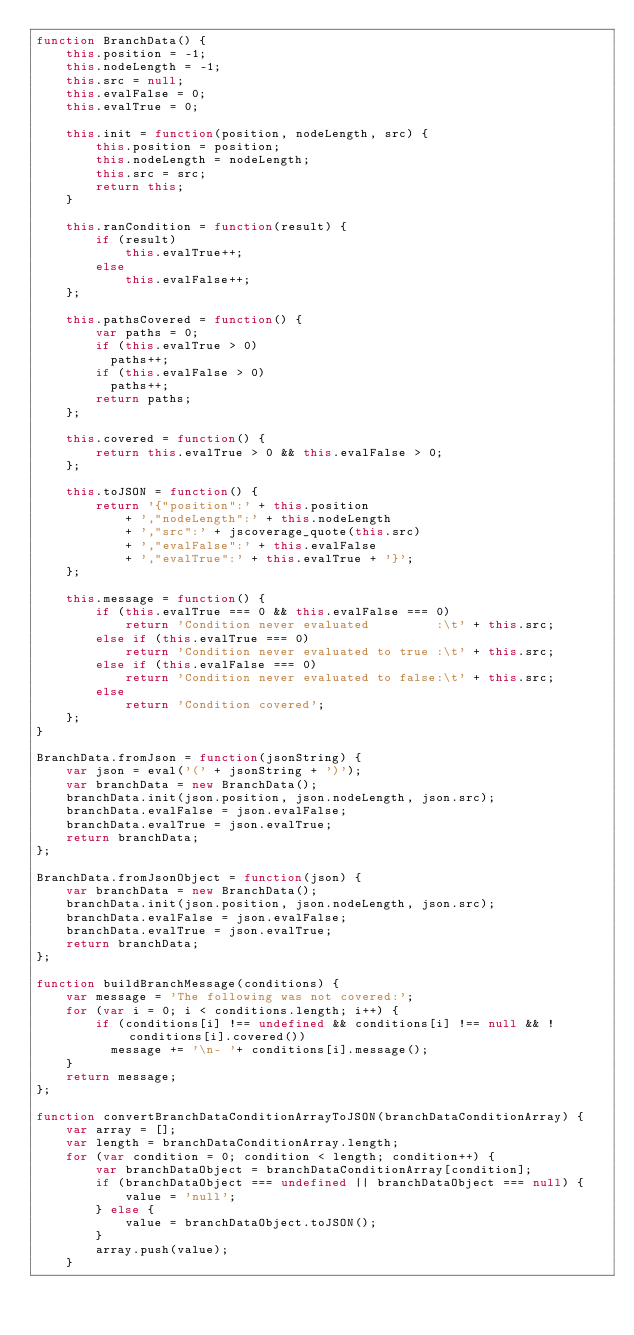Convert code to text. <code><loc_0><loc_0><loc_500><loc_500><_JavaScript_>function BranchData() {
    this.position = -1;
    this.nodeLength = -1;
    this.src = null;
    this.evalFalse = 0;
    this.evalTrue = 0;

    this.init = function(position, nodeLength, src) {
        this.position = position;
        this.nodeLength = nodeLength;
        this.src = src;
        return this;
    }

    this.ranCondition = function(result) {
        if (result)
            this.evalTrue++;
        else
            this.evalFalse++;
    };

    this.pathsCovered = function() {
        var paths = 0;
        if (this.evalTrue > 0)
          paths++;
        if (this.evalFalse > 0)
          paths++;
        return paths;
    };

    this.covered = function() {
        return this.evalTrue > 0 && this.evalFalse > 0;
    };

    this.toJSON = function() {
        return '{"position":' + this.position
            + ',"nodeLength":' + this.nodeLength
            + ',"src":' + jscoverage_quote(this.src)
            + ',"evalFalse":' + this.evalFalse
            + ',"evalTrue":' + this.evalTrue + '}';
    };

    this.message = function() {
        if (this.evalTrue === 0 && this.evalFalse === 0)
            return 'Condition never evaluated         :\t' + this.src;
        else if (this.evalTrue === 0)
            return 'Condition never evaluated to true :\t' + this.src;
        else if (this.evalFalse === 0)
            return 'Condition never evaluated to false:\t' + this.src;
        else
            return 'Condition covered';
    };
}

BranchData.fromJson = function(jsonString) {
    var json = eval('(' + jsonString + ')');
    var branchData = new BranchData();
    branchData.init(json.position, json.nodeLength, json.src);
    branchData.evalFalse = json.evalFalse;
    branchData.evalTrue = json.evalTrue;
    return branchData;
};

BranchData.fromJsonObject = function(json) {
    var branchData = new BranchData();
    branchData.init(json.position, json.nodeLength, json.src);
    branchData.evalFalse = json.evalFalse;
    branchData.evalTrue = json.evalTrue;
    return branchData;
};

function buildBranchMessage(conditions) {
    var message = 'The following was not covered:';
    for (var i = 0; i < conditions.length; i++) {
        if (conditions[i] !== undefined && conditions[i] !== null && !conditions[i].covered())
          message += '\n- '+ conditions[i].message();
    }
    return message;
};

function convertBranchDataConditionArrayToJSON(branchDataConditionArray) {
    var array = [];
    var length = branchDataConditionArray.length;
    for (var condition = 0; condition < length; condition++) {
        var branchDataObject = branchDataConditionArray[condition];
        if (branchDataObject === undefined || branchDataObject === null) {
            value = 'null';
        } else {
            value = branchDataObject.toJSON();
        }
        array.push(value);
    }</code> 